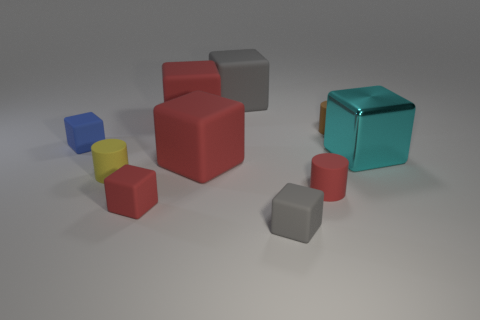Subtract all green cylinders. How many red cubes are left? 3 Subtract all cyan blocks. How many blocks are left? 6 Subtract all big cyan blocks. How many blocks are left? 6 Subtract all purple blocks. Subtract all purple cylinders. How many blocks are left? 7 Subtract all blocks. How many objects are left? 3 Subtract 0 green balls. How many objects are left? 10 Subtract all tiny red rubber cylinders. Subtract all blue things. How many objects are left? 8 Add 4 large red things. How many large red things are left? 6 Add 8 large cyan metal blocks. How many large cyan metal blocks exist? 9 